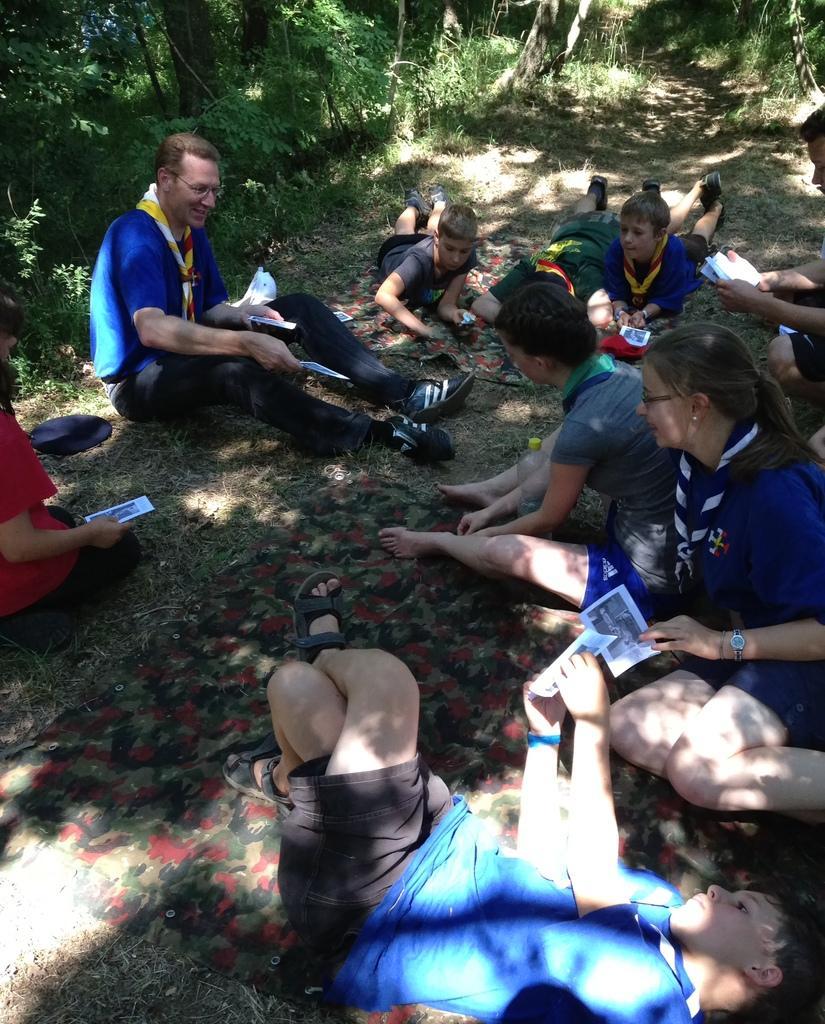In one or two sentences, can you explain what this image depicts? In this image I can see few persons are sitting on the ground and few persons are laying on the ground. I can see few of them are holding papers in their hands. I can see the ground, some grass on the ground and few trees which are green in color in the background. 